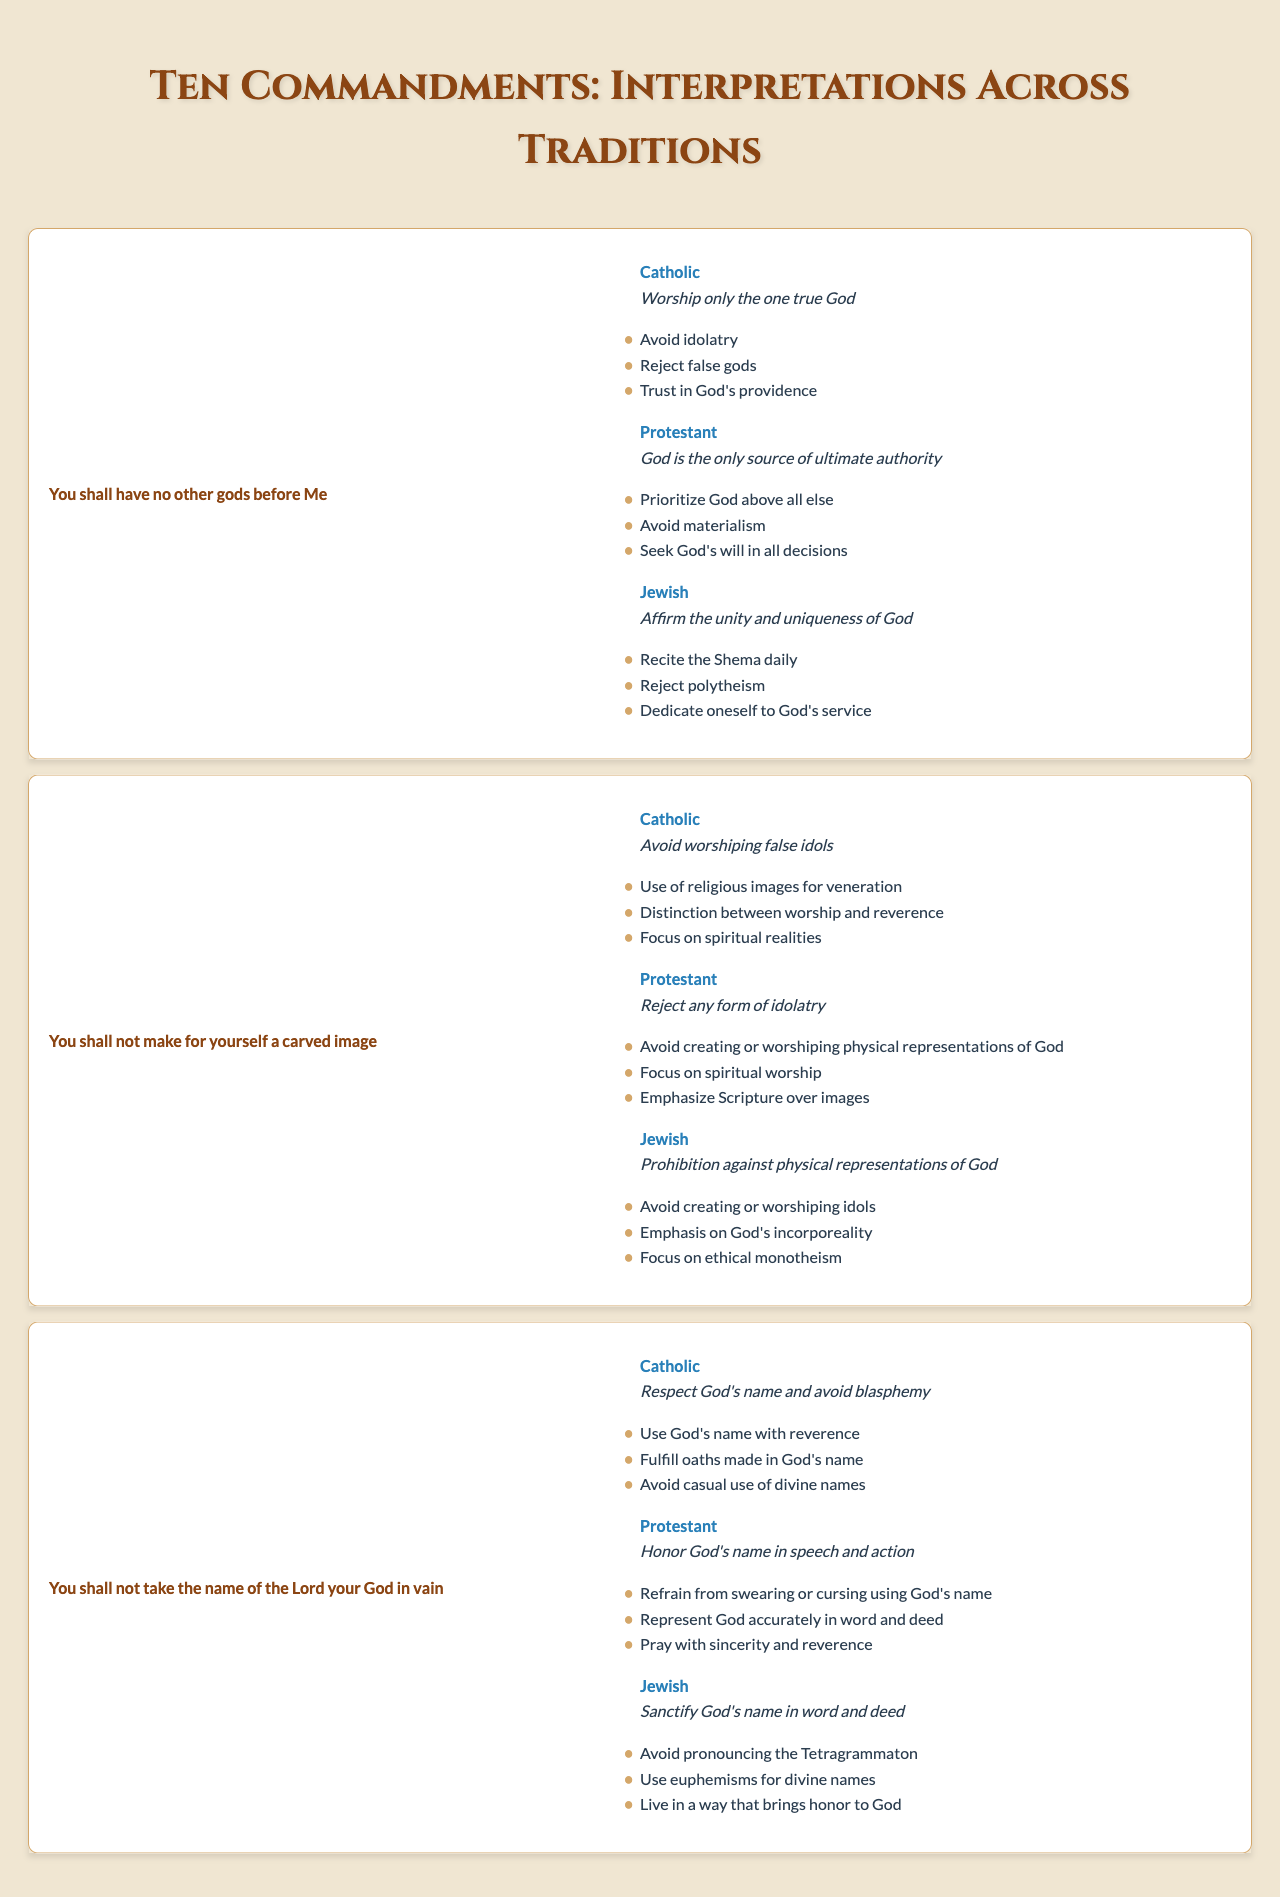What is the interpretation of the first commandment in the Protestant tradition? The table shows that the Protestant interpretation of the first commandment is "God is the only source of ultimate authority".
Answer: God is the only source of ultimate authority Which tradition emphasizes reciting the Shema daily as part of their interpretation of the first commandment? According to the table, the Jewish tradition emphasizes reciting the Shema daily related to their interpretation of the first commandment.
Answer: Jewish tradition Does the Catholic tradition allow for the use of religious images? The table indicates that the Catholic tradition has a distinction between worship and reverence for images, thus allowing the use of religious images for veneration.
Answer: Yes List the key teachings associated with the second commandment in the Protestant tradition. From the table, the key teachings in the Protestant tradition for the second commandment are: Avoid creating or worshiping physical representations of God, focus on spiritual worship, and emphasize Scripture over images.
Answer: Avoid creating or worshiping physical representations of God, focus on spiritual worship, emphasize Scripture over images Which tradition interprets taking God's name in vain as a need to sanctify God's name in word and deed? The table states that the Jewish tradition interprets taking God's name in vain as a need to sanctify God's name in word and deed.
Answer: Jewish tradition Compare the interpretations of the third commandment in the Catholic and Protestant traditions. What is the primary focus of each? The Catholic interpretation focuses on using God's name with reverence and avoiding blasphemy, while the Protestant interpretation emphasizes honoring God's name in speech and action.
Answer: Catholic focuses on reverence; Protestant focuses on honoring in speech and action How many unique key teachings are listed for the second commandment across all traditions? The Catholic tradition lists three teachings, the Protestant tradition lists three, and the Jewish tradition lists three—totaling nine unique teachings.
Answer: Nine unique teachings Is the emphasis on ethical monotheism reflected in the interpretations of the second commandment within the Jewish tradition? Yes, the table confirms that the Jewish interpretation of the second commandment emphasizes ethical monotheism.
Answer: Yes Which commandment has interpretations that stress avoiding idolatry across all traditions? The first commandment shows interpretations from all three traditions emphasizing the rejection of idolatry.
Answer: The first commandment What insight can we gather about the consistent themes regarding God's name from the interpretations of the third commandment? All traditions highlight the importance of respecting and sanctifying God's name through various practices that emphasize reverence and avoidance of misuse in speech.
Answer: They all emphasize respect and sanctification of God's name 